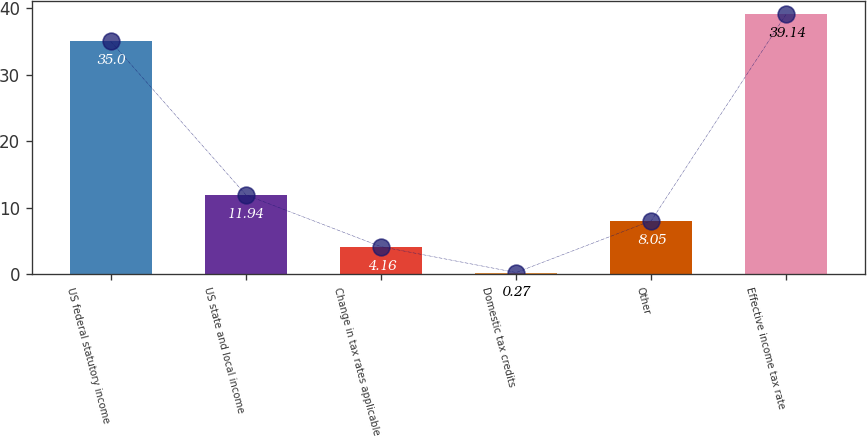<chart> <loc_0><loc_0><loc_500><loc_500><bar_chart><fcel>US federal statutory income<fcel>US state and local income<fcel>Change in tax rates applicable<fcel>Domestic tax credits<fcel>Other<fcel>Effective income tax rate<nl><fcel>35<fcel>11.94<fcel>4.16<fcel>0.27<fcel>8.05<fcel>39.14<nl></chart> 